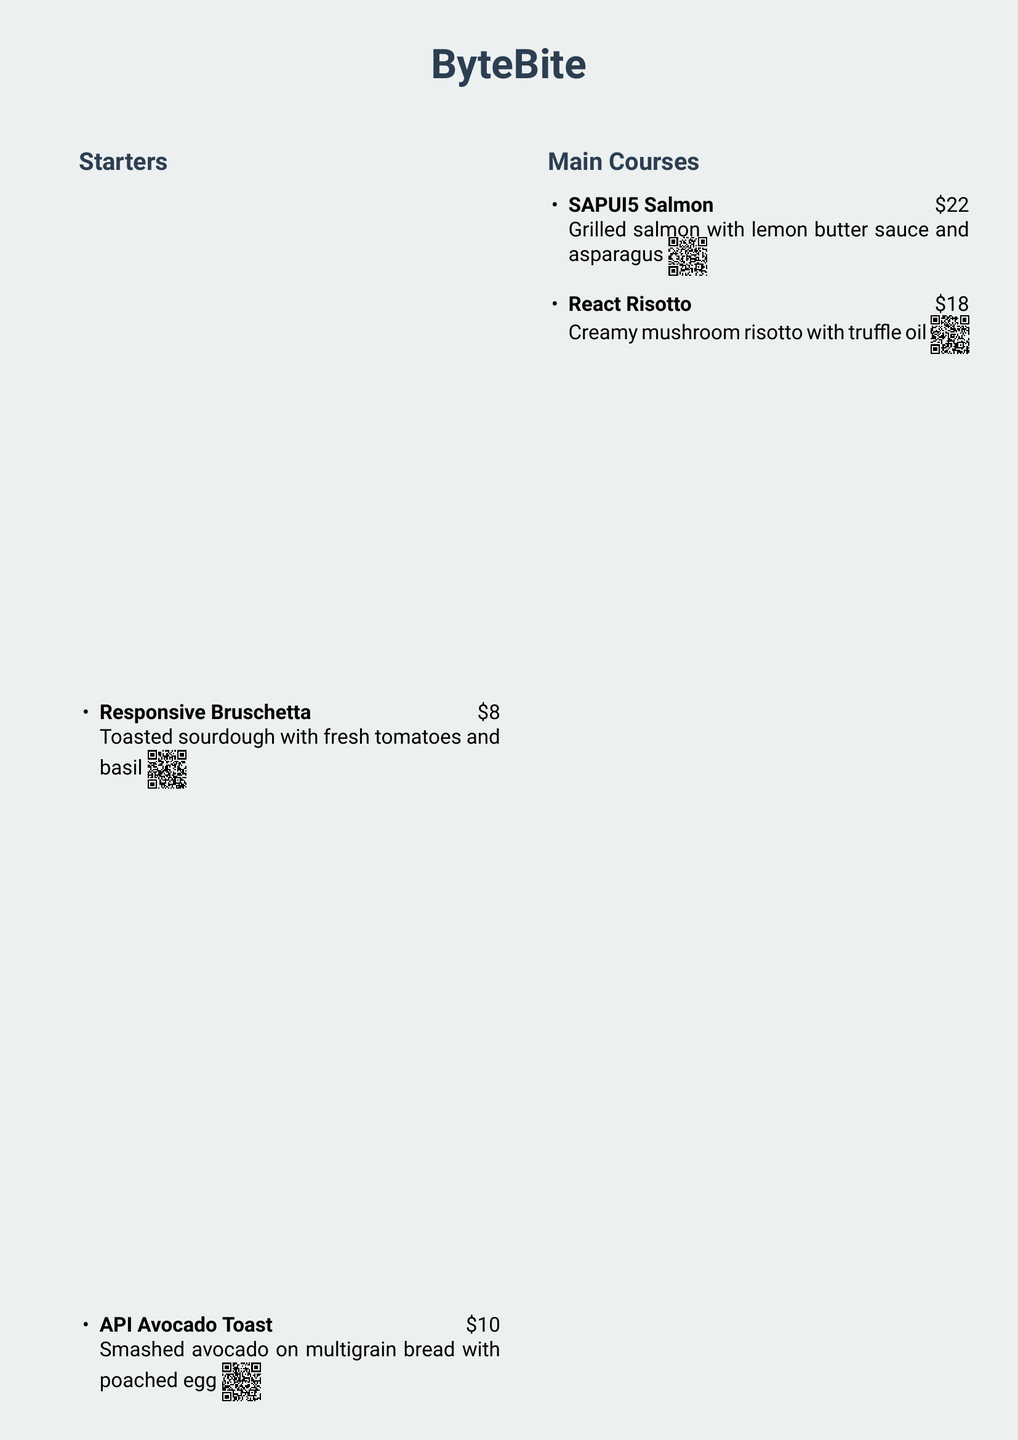What is the name of the restaurant? The name of the restaurant is featured prominently at the top of the menu.
Answer: ByteBite How much does the Responsive Bruschetta cost? The cost is listed next to the item name in the menu.
Answer: $8 What type of dish is the SAPUI5 Salmon? The dish type can be inferred from the menu section where it is listed.
Answer: Main Course What ingredient is included in the API Avocado Toast? The ingredient details are provided in the description of the dish.
Answer: Smashed avocado How many dessert options are listed in the menu? The total number of dessert items can be counted in the menu section.
Answer: 1 What is the preview method for dishes mentioned in the document? The document specifies how customers can view additional information about dishes.
Answer: QR code Which dish has a truffle oil ingredient? The ingredient can be found in the description of the relevant dish.
Answer: React Risotto What color is used for the restaurant's name? The color can be identified in the formatting of the document.
Answer: primaryColor How much is the JavaScript Tiramisu? The price is indicated next to the dessert item name in the menu.
Answer: $9 